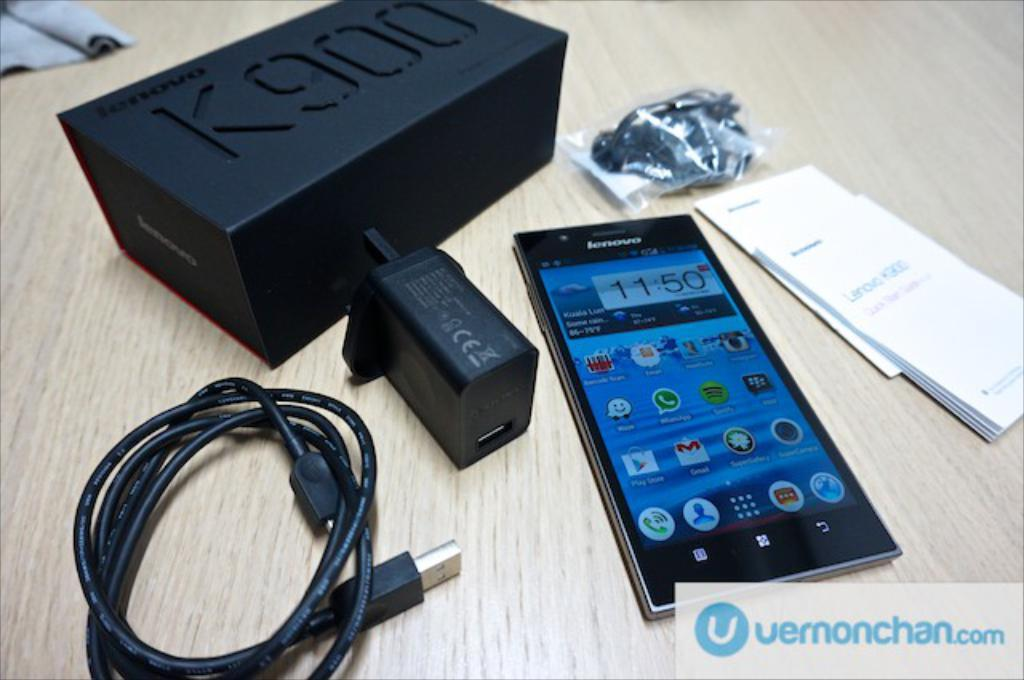<image>
Share a concise interpretation of the image provided. A Lenovo cell phone is laying on a table with a lot of accessories around it. 